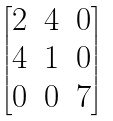Convert formula to latex. <formula><loc_0><loc_0><loc_500><loc_500>\begin{bmatrix} 2 & 4 & 0 \\ 4 & 1 & 0 \\ 0 & 0 & 7 \end{bmatrix}</formula> 